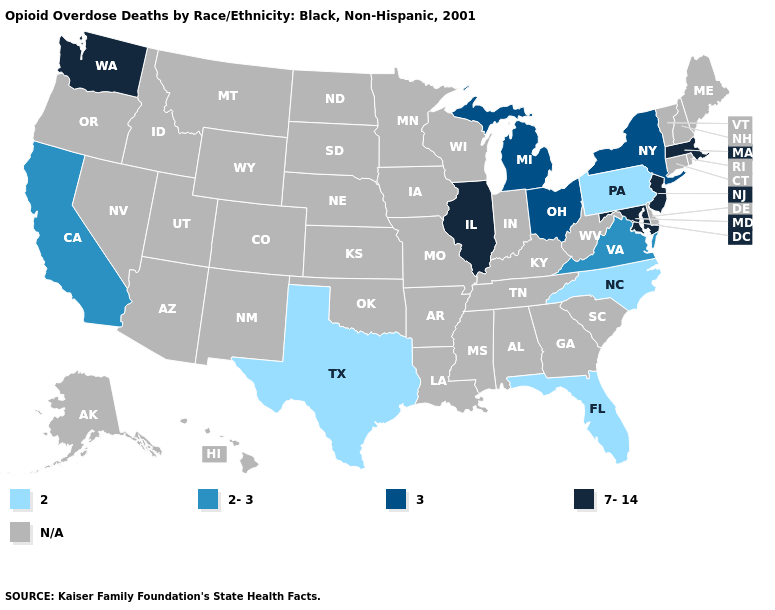What is the value of Rhode Island?
Write a very short answer. N/A. Name the states that have a value in the range 2-3?
Short answer required. California, Virginia. Does the first symbol in the legend represent the smallest category?
Give a very brief answer. Yes. Name the states that have a value in the range 2?
Answer briefly. Florida, North Carolina, Pennsylvania, Texas. What is the value of Utah?
Quick response, please. N/A. Name the states that have a value in the range N/A?
Write a very short answer. Alabama, Alaska, Arizona, Arkansas, Colorado, Connecticut, Delaware, Georgia, Hawaii, Idaho, Indiana, Iowa, Kansas, Kentucky, Louisiana, Maine, Minnesota, Mississippi, Missouri, Montana, Nebraska, Nevada, New Hampshire, New Mexico, North Dakota, Oklahoma, Oregon, Rhode Island, South Carolina, South Dakota, Tennessee, Utah, Vermont, West Virginia, Wisconsin, Wyoming. Name the states that have a value in the range N/A?
Write a very short answer. Alabama, Alaska, Arizona, Arkansas, Colorado, Connecticut, Delaware, Georgia, Hawaii, Idaho, Indiana, Iowa, Kansas, Kentucky, Louisiana, Maine, Minnesota, Mississippi, Missouri, Montana, Nebraska, Nevada, New Hampshire, New Mexico, North Dakota, Oklahoma, Oregon, Rhode Island, South Carolina, South Dakota, Tennessee, Utah, Vermont, West Virginia, Wisconsin, Wyoming. Which states hav the highest value in the Northeast?
Quick response, please. Massachusetts, New Jersey. Which states hav the highest value in the West?
Keep it brief. Washington. Does Texas have the highest value in the South?
Be succinct. No. Is the legend a continuous bar?
Be succinct. No. Does Texas have the lowest value in the South?
Short answer required. Yes. What is the lowest value in the USA?
Write a very short answer. 2. 